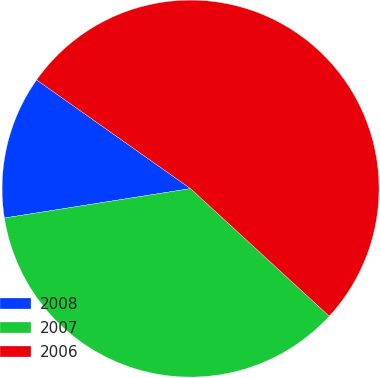<chart> <loc_0><loc_0><loc_500><loc_500><pie_chart><fcel>2008<fcel>2007<fcel>2006<nl><fcel>12.28%<fcel>35.67%<fcel>52.05%<nl></chart> 